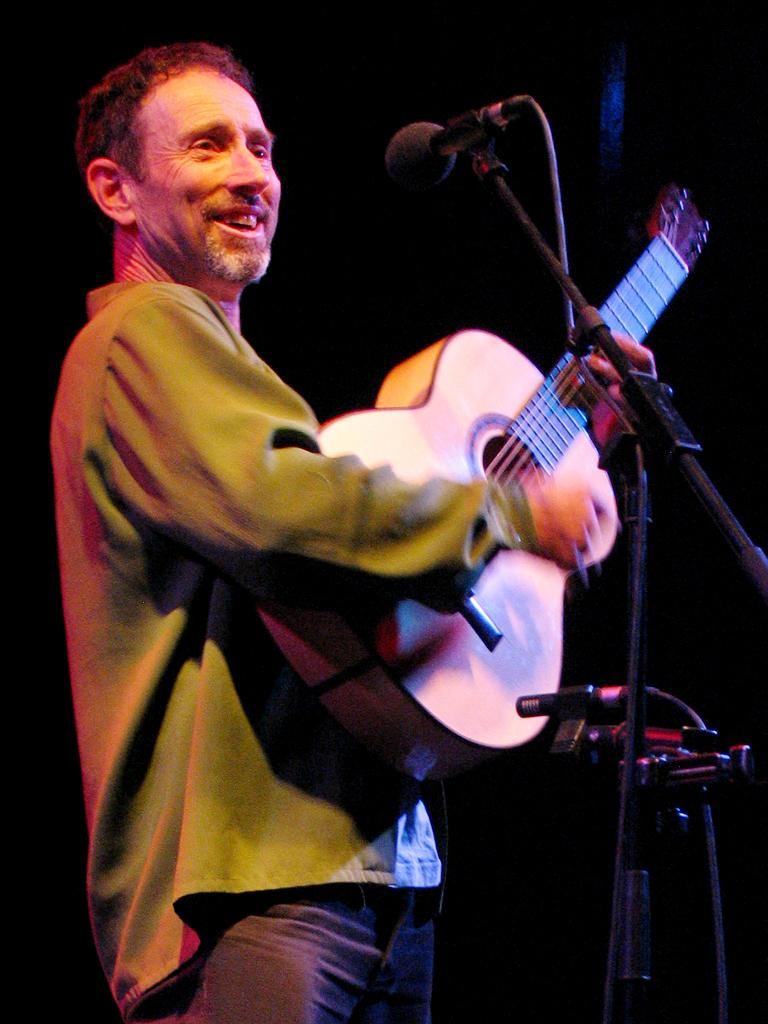What is the man in the image doing? The man is playing a guitar in the image. What expression does the man have on his face? The man is smiling in the image. What is in front of the man? There is a microphone and a stand in front of the man. What can be observed about the background of the image? The background of the image is dark. Can you tell me how many horses are present in the image? There are no horses present in the image. What type of monkey can be seen interacting with the man in the image? There is no monkey present in the image; the man is playing a guitar by himself. 